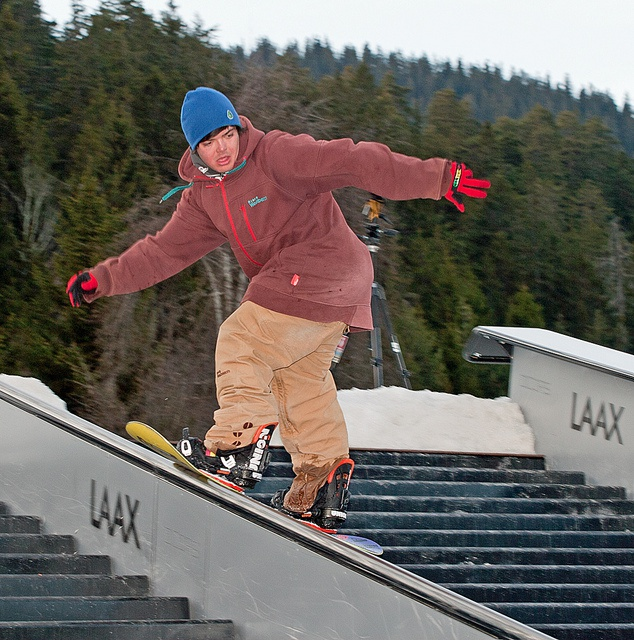Describe the objects in this image and their specific colors. I can see people in black, brown, tan, and maroon tones and snowboard in black, tan, gray, orange, and darkgray tones in this image. 